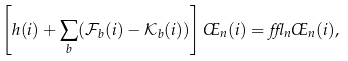Convert formula to latex. <formula><loc_0><loc_0><loc_500><loc_500>\left [ h ( i ) + \sum _ { b } ( \mathcal { F } _ { b } ( i ) - \mathcal { K } _ { b } ( i ) ) \right ] \phi _ { n } ( i ) = \epsilon _ { n } \phi _ { n } ( i ) ,</formula> 